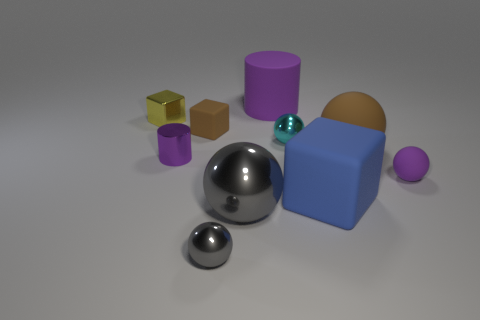What is the color of the tiny object that is to the left of the large cylinder and on the right side of the small brown block?
Your response must be concise. Gray. Do the rubber cube that is to the left of the blue object and the big brown ball have the same size?
Provide a short and direct response. No. What number of objects are metal spheres left of the matte cylinder or rubber cubes?
Your answer should be very brief. 4. Are there any blue rubber objects that have the same size as the purple ball?
Your answer should be very brief. No. There is a gray thing that is the same size as the blue thing; what is its material?
Provide a succinct answer. Metal. The metallic object that is behind the large brown sphere and right of the yellow block has what shape?
Offer a terse response. Sphere. There is a big object behind the tiny cyan thing; what is its color?
Give a very brief answer. Purple. How big is the thing that is on the left side of the big gray object and in front of the big rubber block?
Offer a terse response. Small. Does the big blue cube have the same material as the ball that is to the left of the large gray metallic thing?
Keep it short and to the point. No. What number of small purple objects have the same shape as the tiny gray thing?
Your response must be concise. 1. 